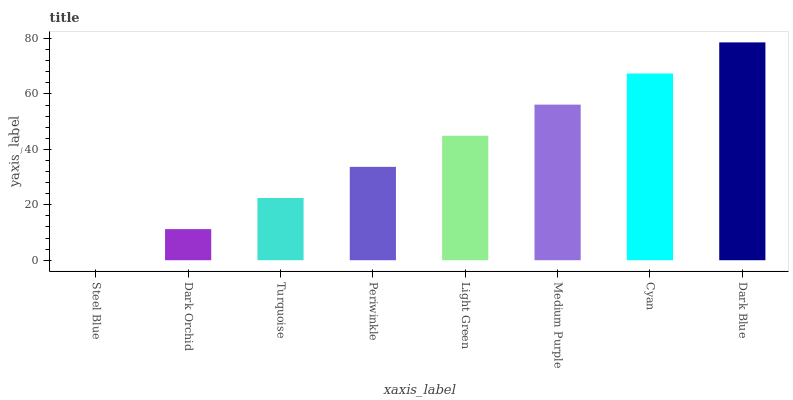Is Steel Blue the minimum?
Answer yes or no. Yes. Is Dark Blue the maximum?
Answer yes or no. Yes. Is Dark Orchid the minimum?
Answer yes or no. No. Is Dark Orchid the maximum?
Answer yes or no. No. Is Dark Orchid greater than Steel Blue?
Answer yes or no. Yes. Is Steel Blue less than Dark Orchid?
Answer yes or no. Yes. Is Steel Blue greater than Dark Orchid?
Answer yes or no. No. Is Dark Orchid less than Steel Blue?
Answer yes or no. No. Is Light Green the high median?
Answer yes or no. Yes. Is Periwinkle the low median?
Answer yes or no. Yes. Is Dark Blue the high median?
Answer yes or no. No. Is Cyan the low median?
Answer yes or no. No. 